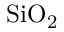<formula> <loc_0><loc_0><loc_500><loc_500>{ S i O _ { 2 } }</formula> 